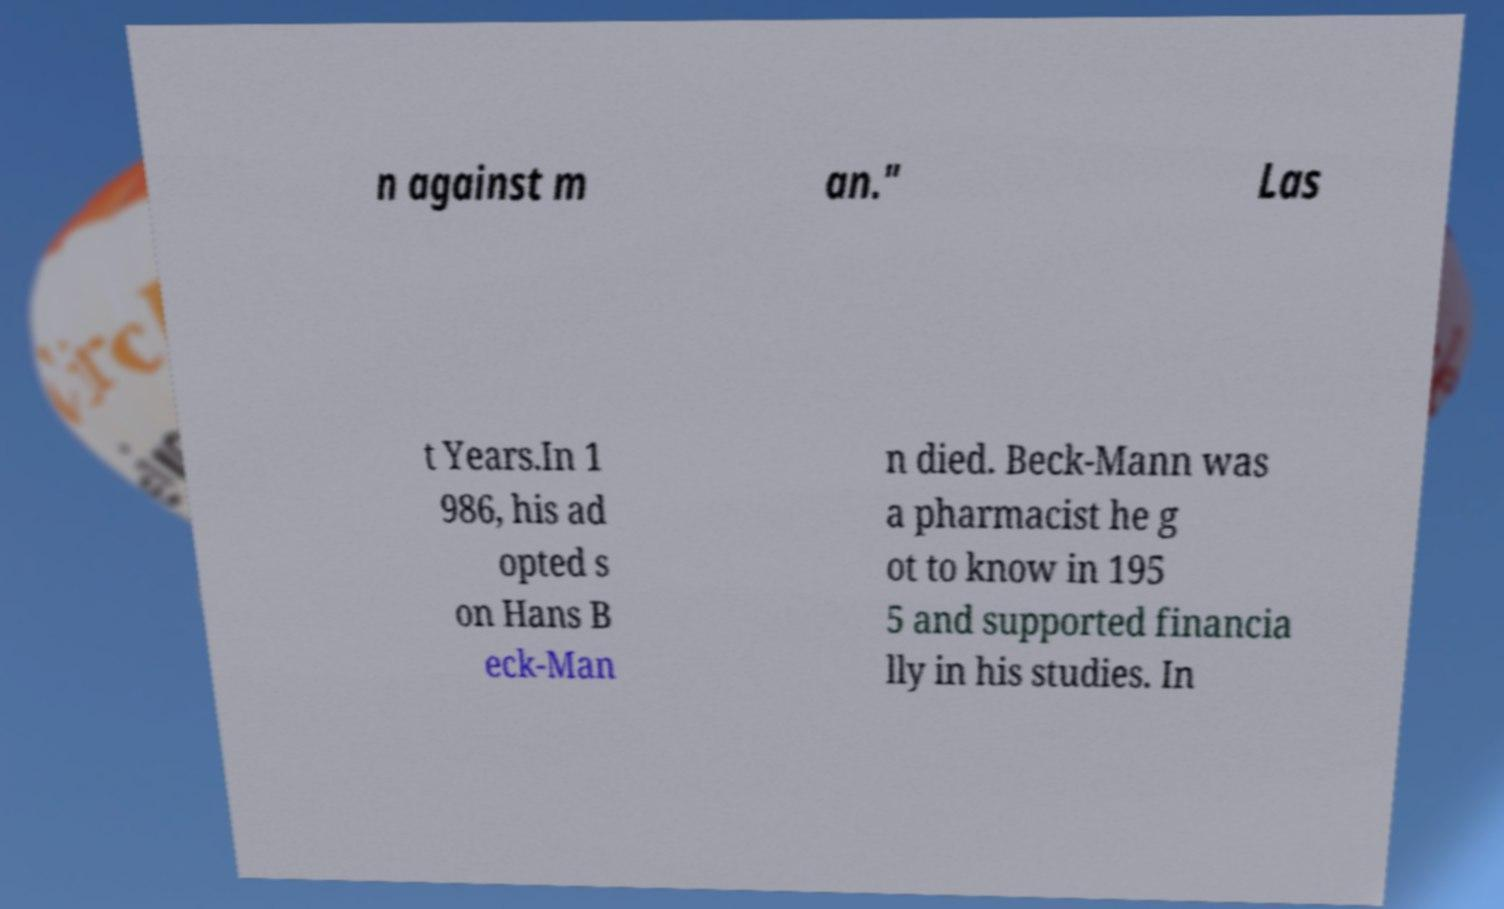Please read and relay the text visible in this image. What does it say? n against m an." Las t Years.In 1 986, his ad opted s on Hans B eck-Man n died. Beck-Mann was a pharmacist he g ot to know in 195 5 and supported financia lly in his studies. In 